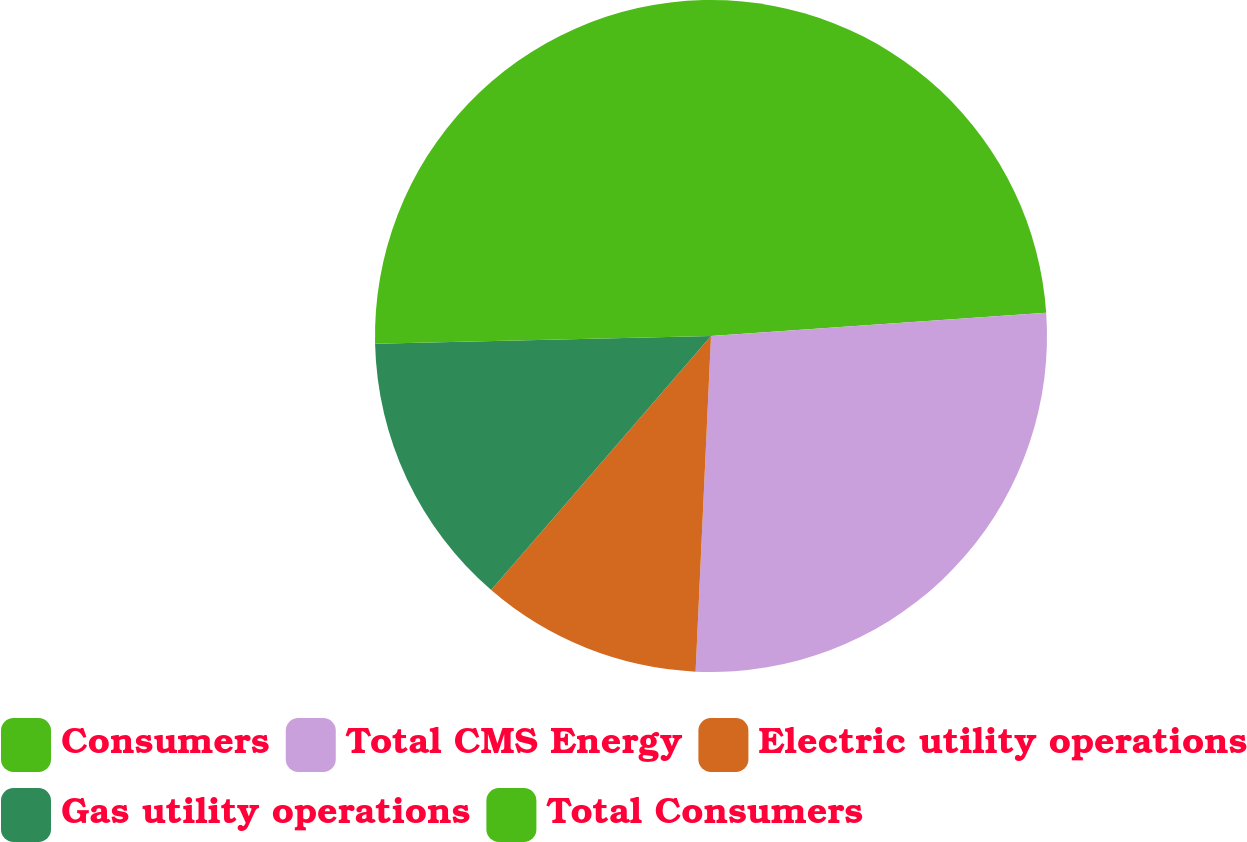<chart> <loc_0><loc_0><loc_500><loc_500><pie_chart><fcel>Consumers<fcel>Total CMS Energy<fcel>Electric utility operations<fcel>Gas utility operations<fcel>Total Consumers<nl><fcel>23.9%<fcel>26.83%<fcel>10.62%<fcel>13.28%<fcel>25.37%<nl></chart> 